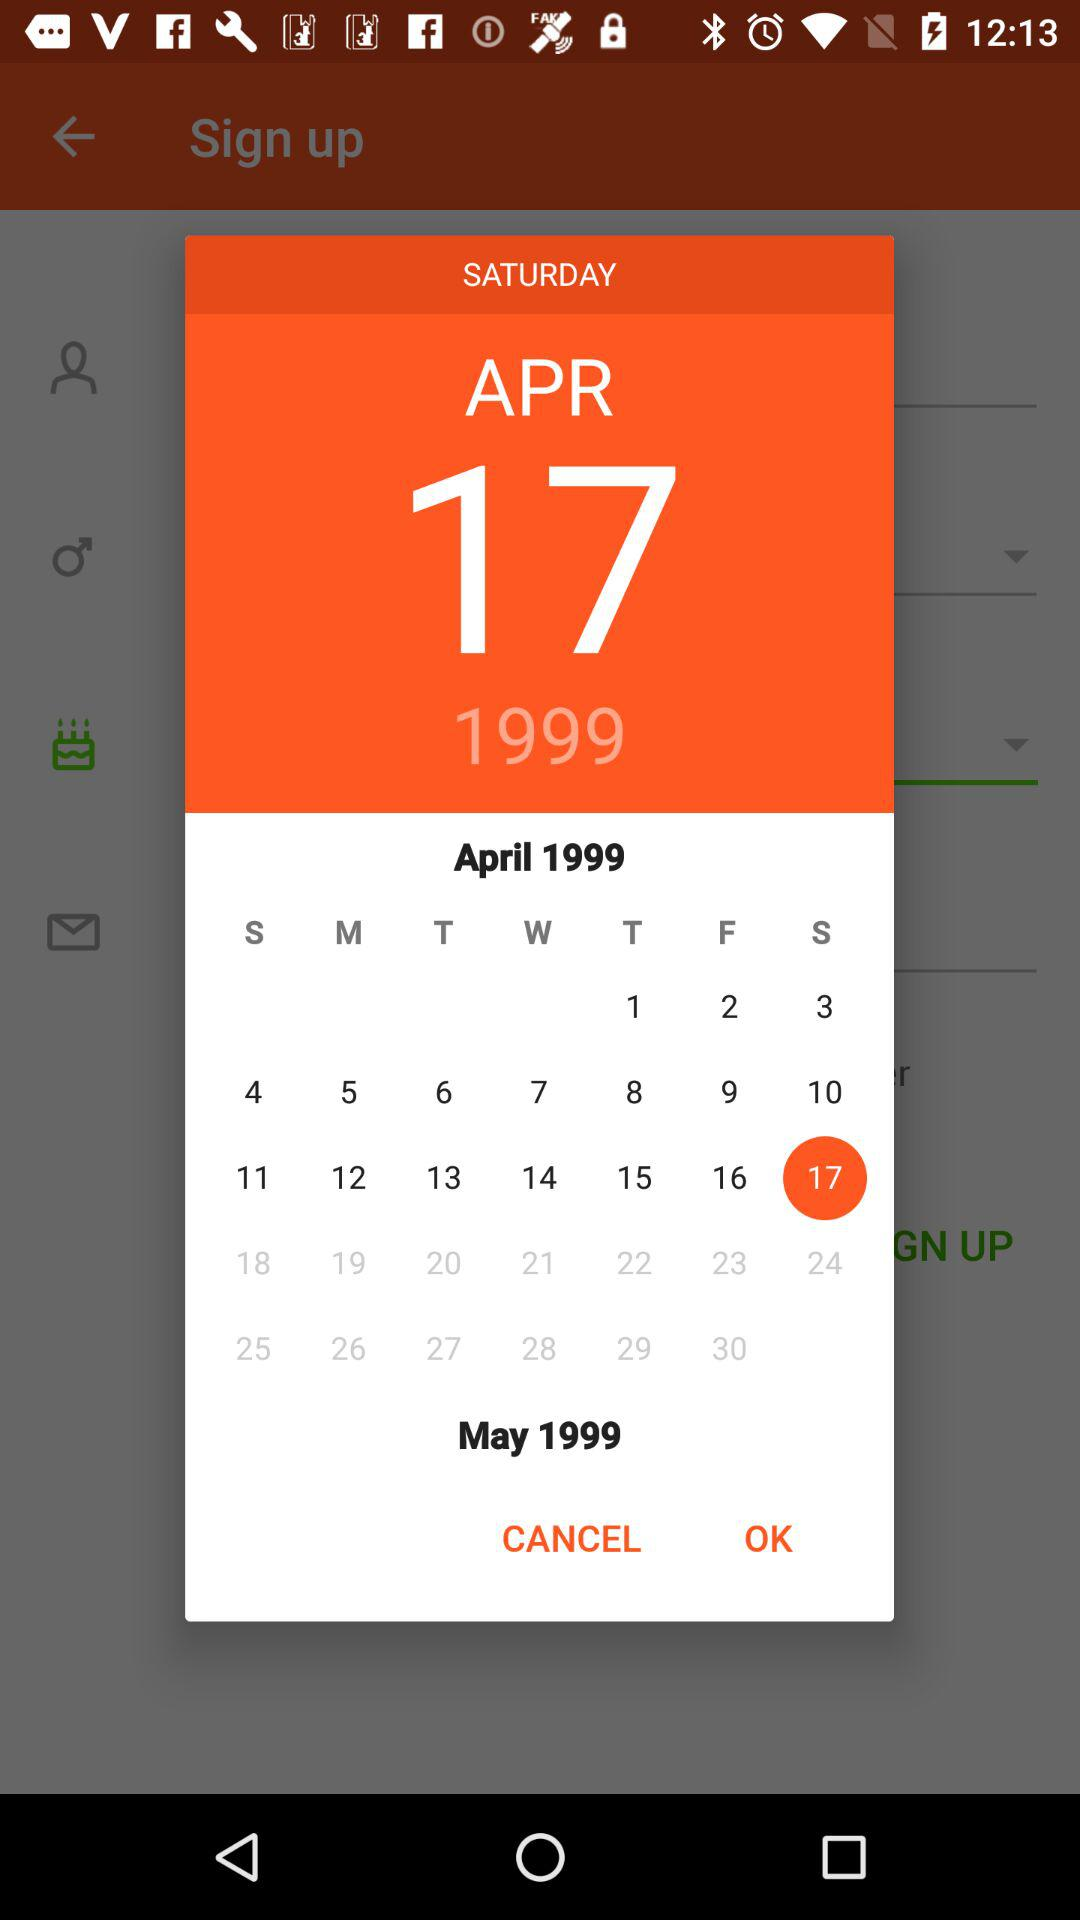What day is it on April 17, 1999? The day is Saturday. 